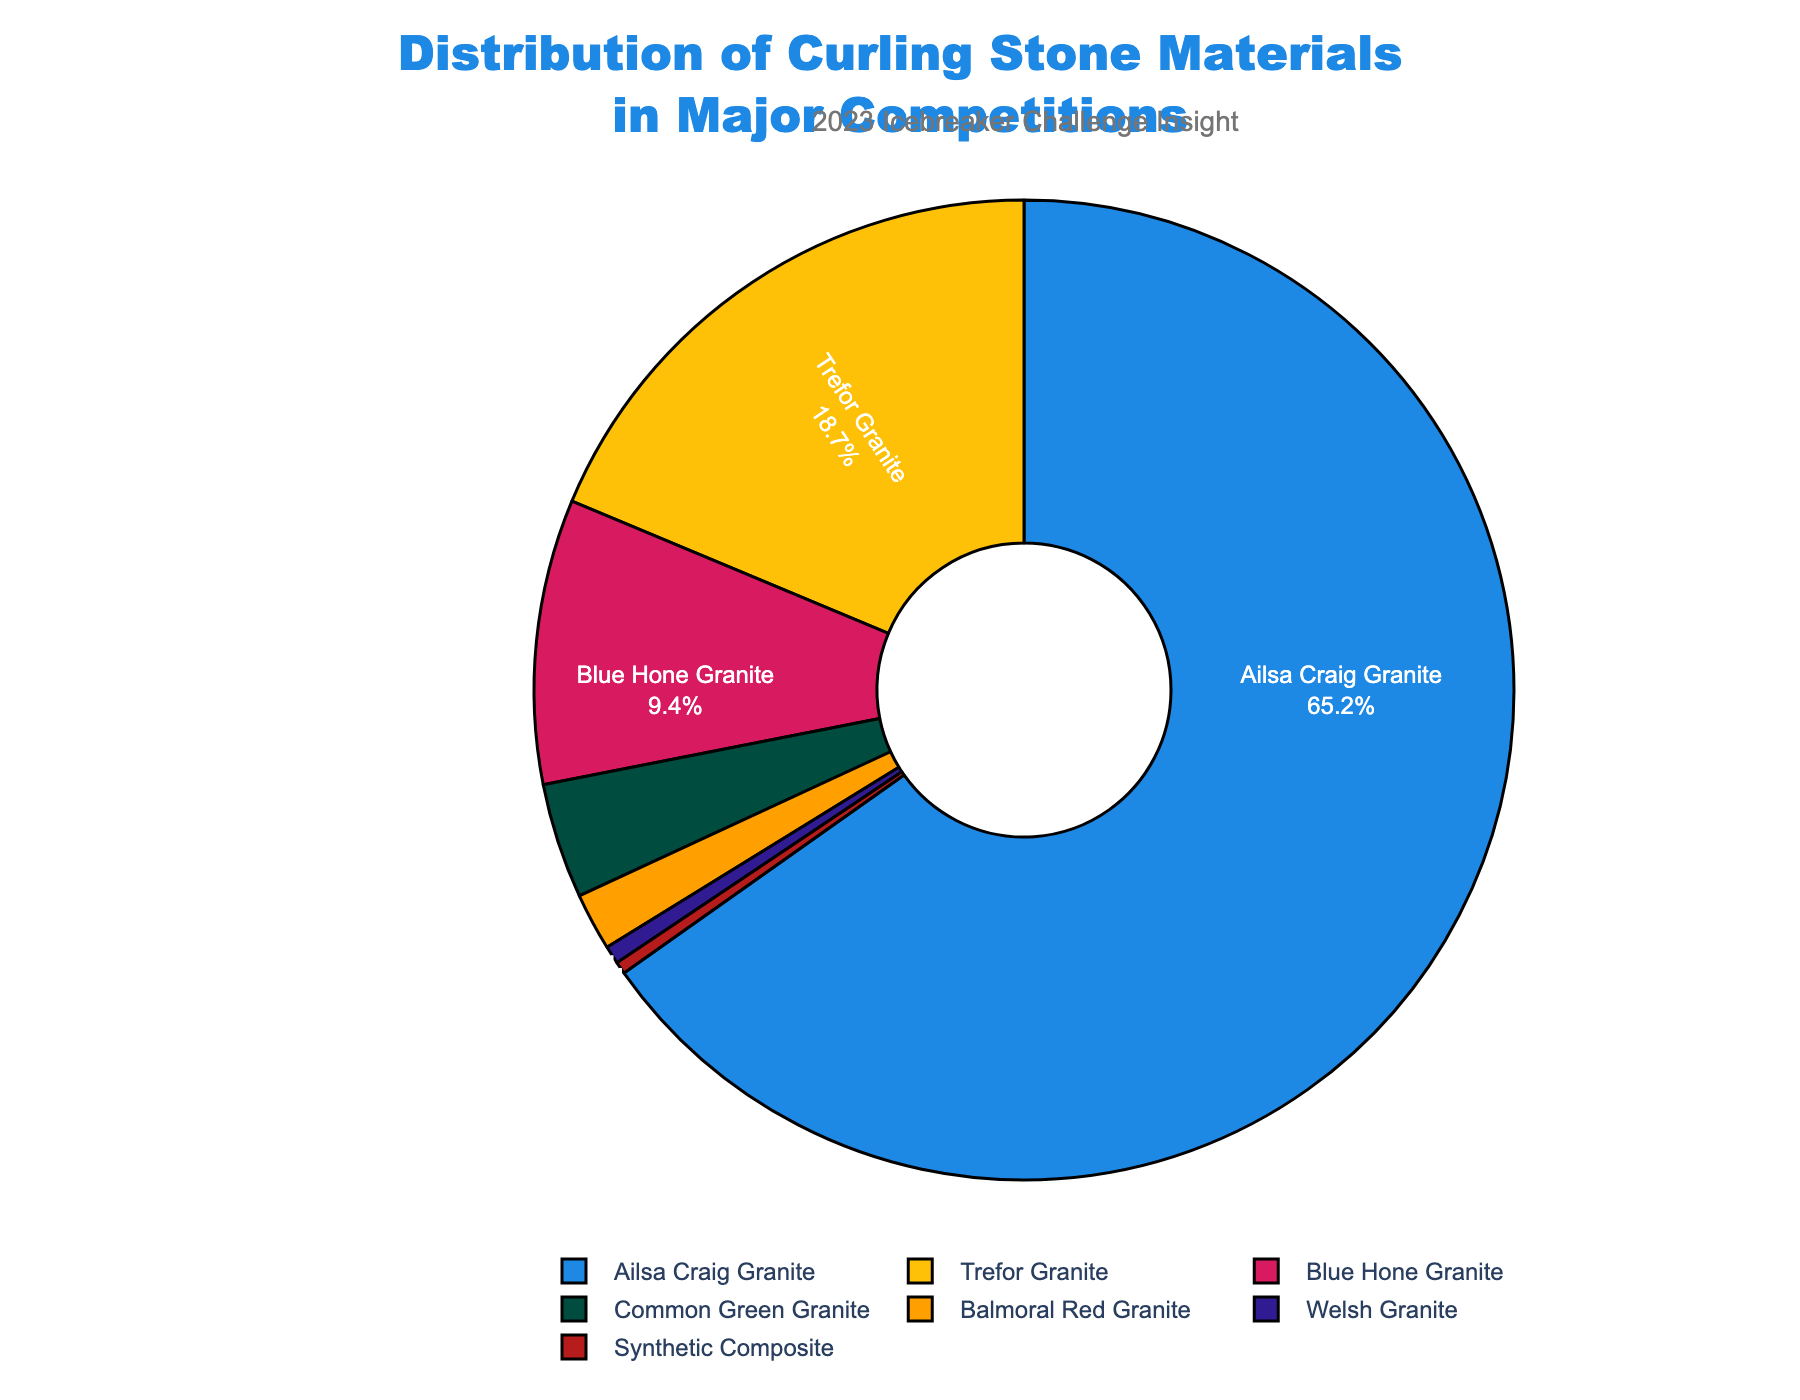What is the most common material used for curling stones in major competitions? The pie chart shows the distribution of curling stone materials, with Ailsa Craig Granite having the largest portion.
Answer: Ailsa Craig Granite Which material has the smallest representation in the distribution of curling stone materials? The pie chart indicates that Synthetic Composite has the smallest slice.
Answer: Synthetic Composite What is the combined percentage of Trefor Granite and Blue Hone Granite used in major competitions? Looking at the pie chart, Trefor Granite is 18.7% and Blue Hone Granite is 9.4%. Adding these together gives 18.7% + 9.4% = 28.1%.
Answer: 28.1% How much more common is Ailsa Craig Granite compared to Common Green Granite? Ailsa Craig Granite is 65.2% while Common Green Granite is 3.8%. The difference is 65.2% - 3.8% = 61.4%.
Answer: 61.4% Which material is more prevalent: Balmoral Red Granite or Welsh Granite, and by how much? Balmoral Red Granite has a percentage of 1.9%, and Welsh Granite has 0.6%. Balmoral Red Granite is more prevalent by 1.9% - 0.6% = 1.3%.
Answer: Balmoral Red Granite by 1.3% What is the total percentage of materials other than Ailsa Craig Granite? Adding the percentages of all other materials: 18.7% (Trefor Granite) + 9.4% (Blue Hone Granite) + 3.8% (Common Green Granite) + 1.9% (Balmoral Red Granite) + 0.6% (Welsh Granite) + 0.4% (Synthetic Composite) = 34.8%.
Answer: 34.8% What materials form less than 5% of the total distribution? The pie chart shows that Common Green Granite, Balmoral Red Granite, Welsh Granite, and Synthetic Composite are all less than 5%.
Answer: Common Green Granite, Balmoral Red Granite, Welsh Granite, Synthetic Composite Between Trefor Granite and Blue Hone Granite, which one has a higher usage percentage? The pie chart shows Trefor Granite at 18.7% and Blue Hone Granite at 9.4%. Thus, Trefor Granite has a higher usage percentage.
Answer: Trefor Granite How does the usage of Blue Hone Granite compare to the combined usage of Balmoral Red Granite and Welsh Granite? Blue Hone Granite has a percentage of 9.4%. Balmoral Red Granite is 1.9%, and Welsh Granite is 0.6%, so their combined usage is 1.9% + 0.6% = 2.5%. Blue Hone Granite is 9.4% - 2.5% = 6.9% more.
Answer: 6.9% more 